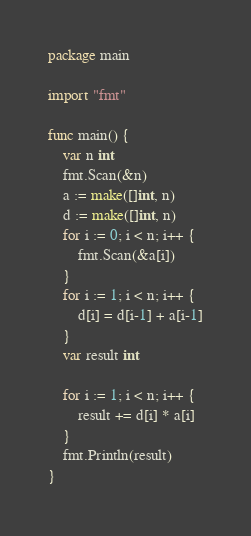<code> <loc_0><loc_0><loc_500><loc_500><_Go_>package main

import "fmt"

func main() {
	var n int
	fmt.Scan(&n)
	a := make([]int, n)
	d := make([]int, n)
	for i := 0; i < n; i++ {
		fmt.Scan(&a[i])
	}
	for i := 1; i < n; i++ {
		d[i] = d[i-1] + a[i-1]
	}
	var result int

	for i := 1; i < n; i++ {
		result += d[i] * a[i]
	}
	fmt.Println(result)
}
</code> 